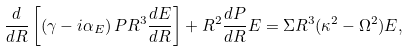<formula> <loc_0><loc_0><loc_500><loc_500>\frac { d } { d R } \left [ \left ( \gamma - i \alpha _ { E } \right ) P R ^ { 3 } \frac { d E } { d R } \right ] + R ^ { 2 } \frac { d P } { d R } E = \Sigma R ^ { 3 } ( \kappa ^ { 2 } - \Omega ^ { 2 } ) E ,</formula> 